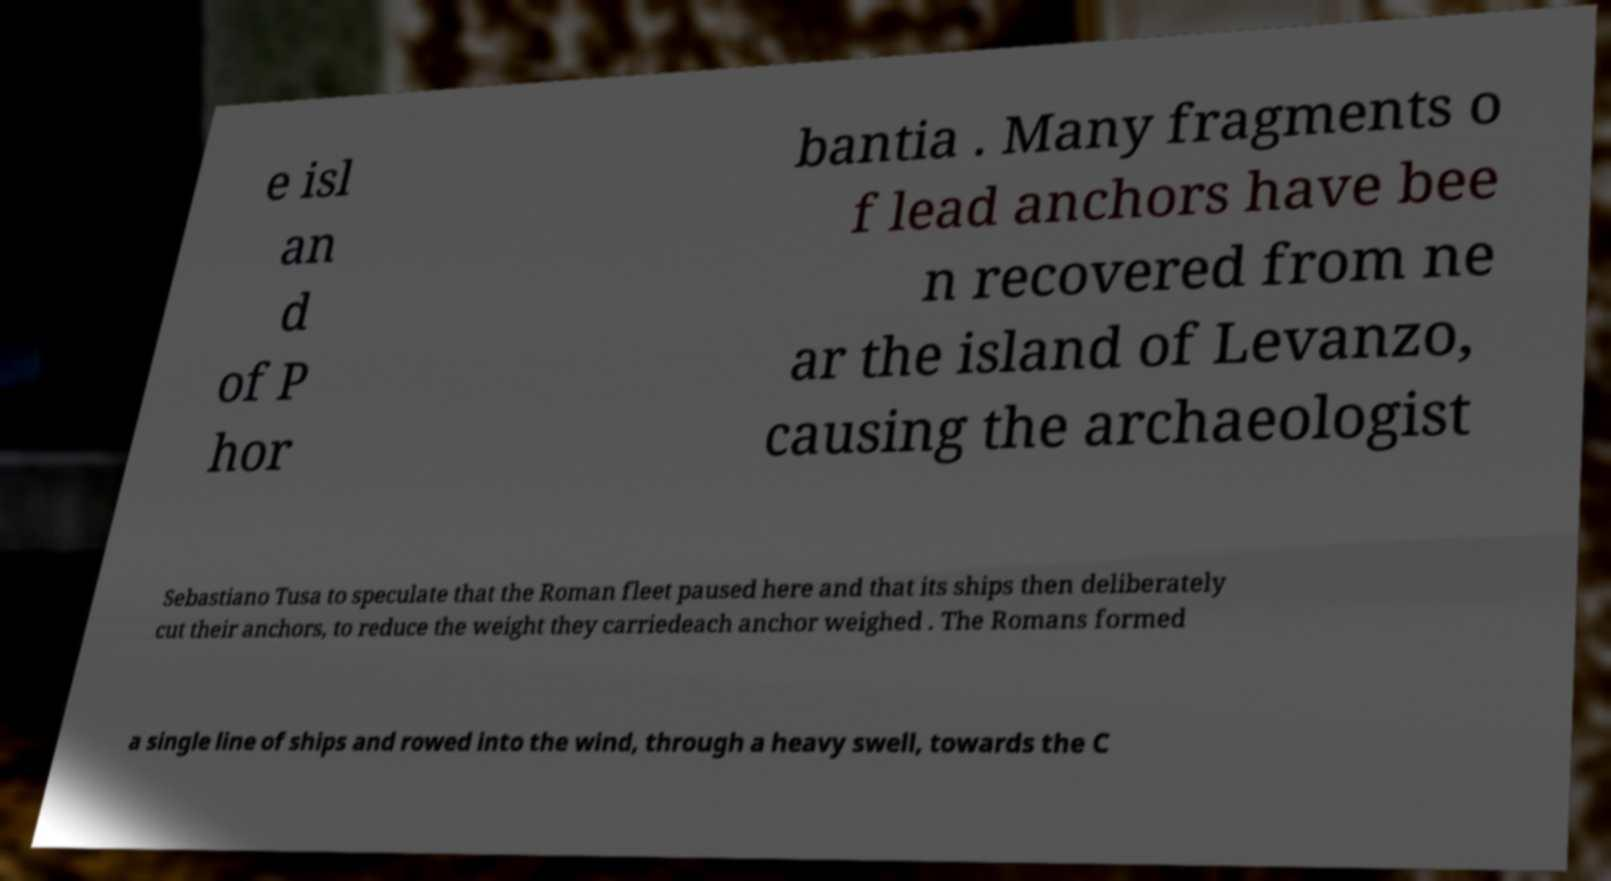There's text embedded in this image that I need extracted. Can you transcribe it verbatim? e isl an d of P hor bantia . Many fragments o f lead anchors have bee n recovered from ne ar the island of Levanzo, causing the archaeologist Sebastiano Tusa to speculate that the Roman fleet paused here and that its ships then deliberately cut their anchors, to reduce the weight they carriedeach anchor weighed . The Romans formed a single line of ships and rowed into the wind, through a heavy swell, towards the C 